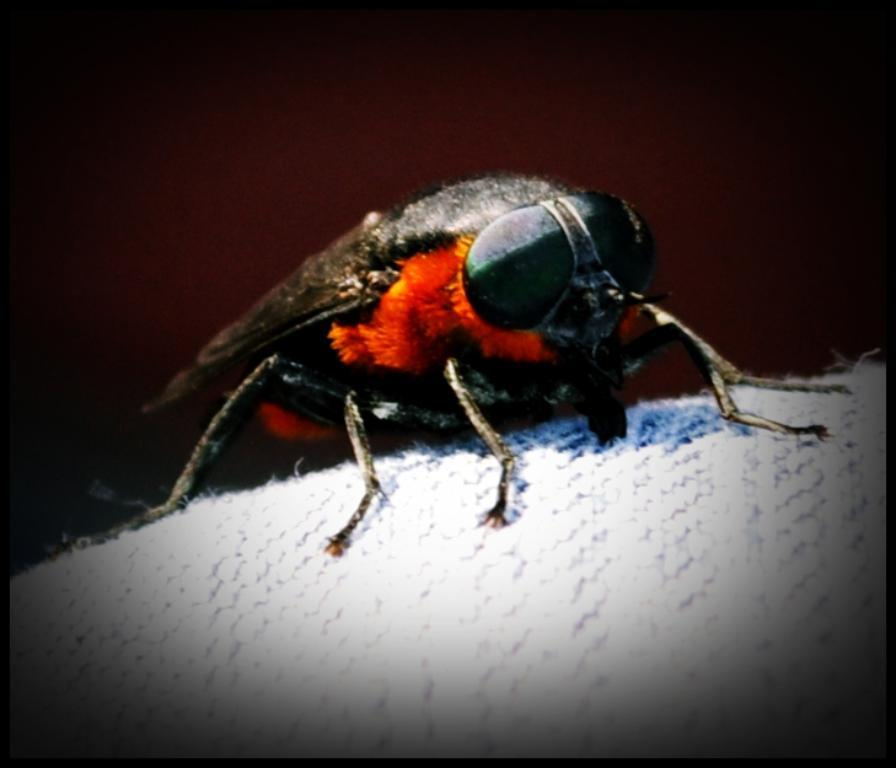What type of insect is in the image? There is a hornet in the image. Where is the hornet located in the image? The hornet is in the center of the image. What type of skate is visible in the image? There is no skate present in the image; it features a hornet. What type of clam is the hornet using as a business in the image? There is no clam or business involving a hornet in the image. 